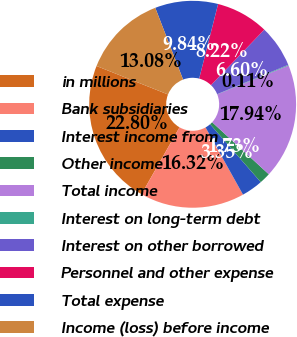<chart> <loc_0><loc_0><loc_500><loc_500><pie_chart><fcel>in millions<fcel>Bank subsidiaries<fcel>Interest income from<fcel>Other income<fcel>Total income<fcel>Interest on long-term debt<fcel>Interest on other borrowed<fcel>Personnel and other expense<fcel>Total expense<fcel>Income (loss) before income<nl><fcel>22.8%<fcel>16.32%<fcel>3.35%<fcel>1.73%<fcel>17.94%<fcel>0.11%<fcel>6.6%<fcel>8.22%<fcel>9.84%<fcel>13.08%<nl></chart> 